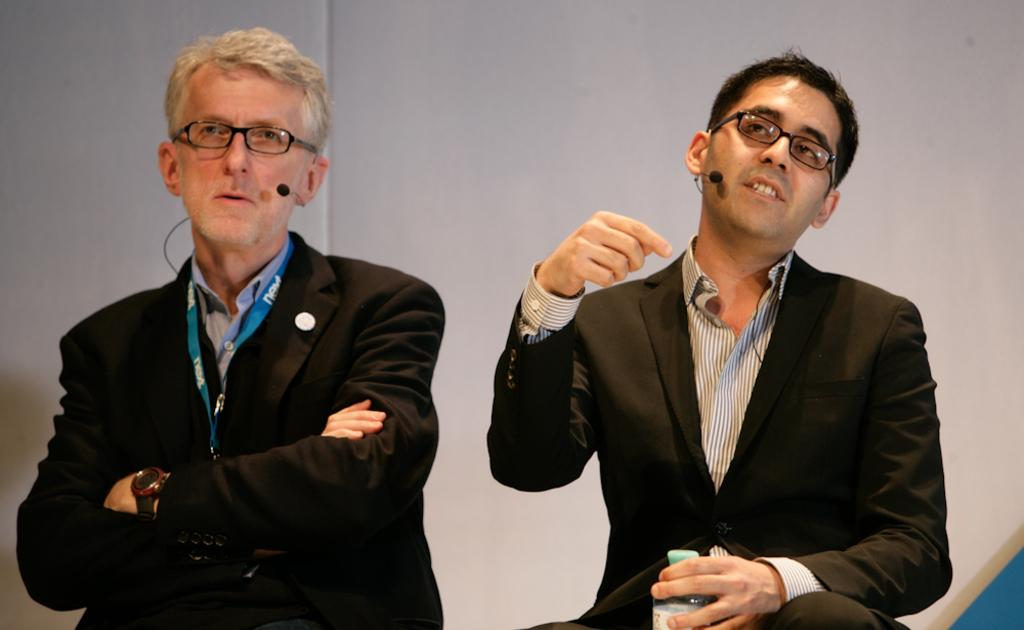How many persons are present in the image? There are two persons in the image. What are the persons doing in the image? The persons are sitting on chairs. What can be seen in the background of the image? There is a wall in the background of the image. What type of order is the monkey following in the image? There is no monkey present in the image, so it is not possible to determine what order it might be following. 